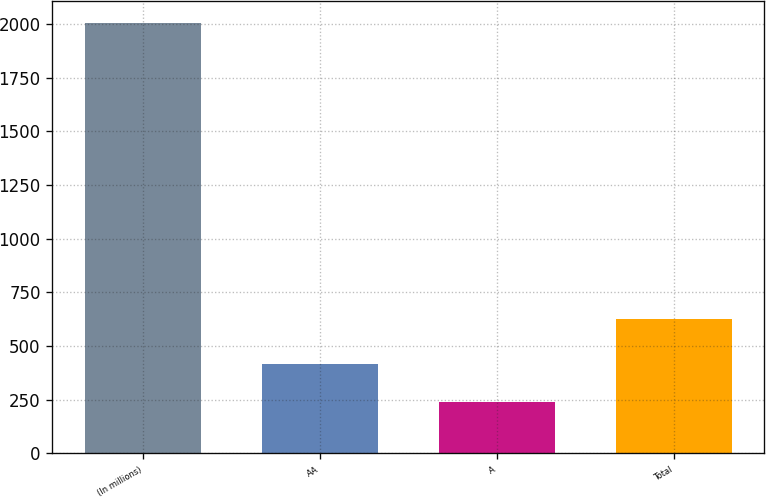<chart> <loc_0><loc_0><loc_500><loc_500><bar_chart><fcel>(In millions)<fcel>AA<fcel>A<fcel>Total<nl><fcel>2007<fcel>414.9<fcel>238<fcel>625<nl></chart> 